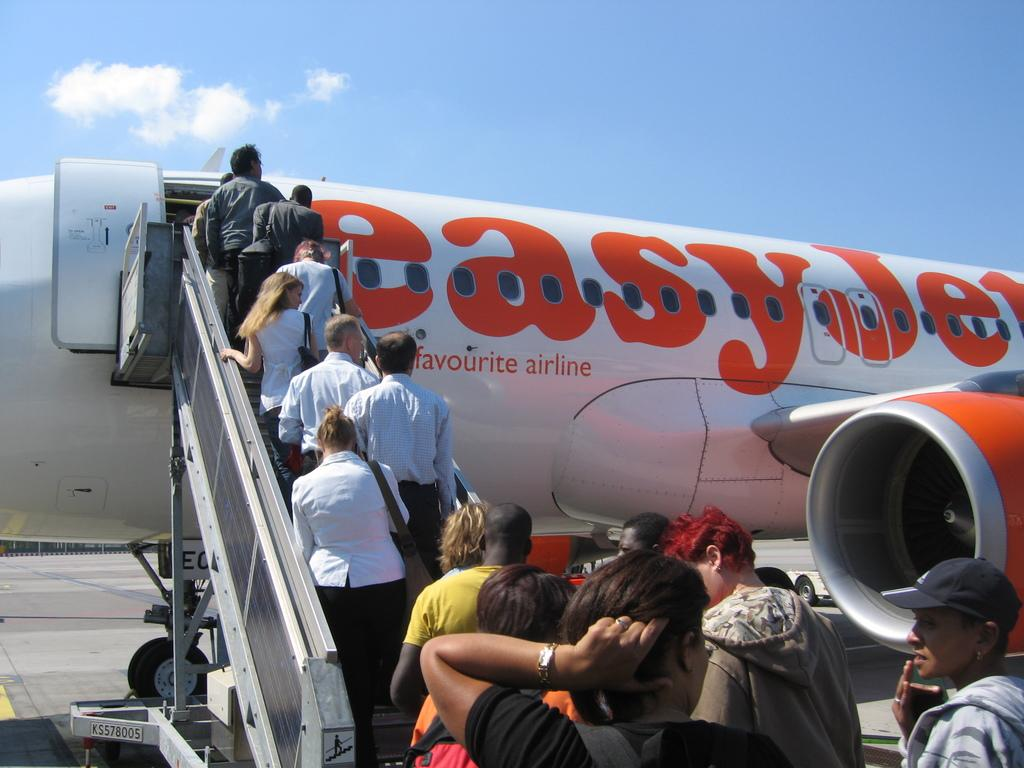Provide a one-sentence caption for the provided image. Several people are boarding an easyJet plane outdoors. 